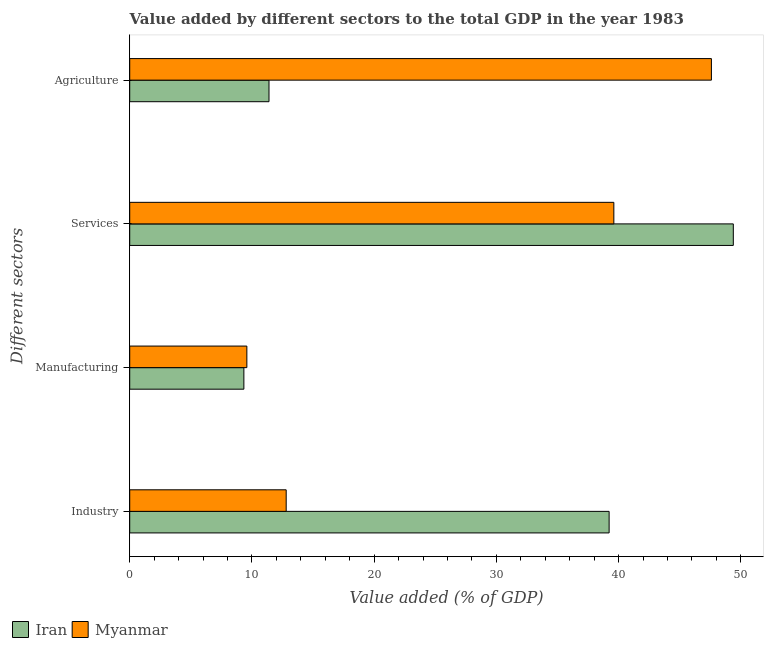How many different coloured bars are there?
Offer a very short reply. 2. How many groups of bars are there?
Provide a short and direct response. 4. Are the number of bars per tick equal to the number of legend labels?
Your answer should be compact. Yes. Are the number of bars on each tick of the Y-axis equal?
Your answer should be very brief. Yes. How many bars are there on the 2nd tick from the top?
Make the answer very short. 2. What is the label of the 2nd group of bars from the top?
Give a very brief answer. Services. What is the value added by industrial sector in Myanmar?
Provide a succinct answer. 12.8. Across all countries, what is the maximum value added by manufacturing sector?
Make the answer very short. 9.58. Across all countries, what is the minimum value added by manufacturing sector?
Ensure brevity in your answer.  9.34. In which country was the value added by industrial sector maximum?
Ensure brevity in your answer.  Iran. In which country was the value added by manufacturing sector minimum?
Offer a very short reply. Iran. What is the total value added by industrial sector in the graph?
Offer a very short reply. 52.02. What is the difference between the value added by industrial sector in Myanmar and that in Iran?
Your answer should be compact. -26.42. What is the difference between the value added by industrial sector in Myanmar and the value added by agricultural sector in Iran?
Give a very brief answer. 1.41. What is the average value added by agricultural sector per country?
Ensure brevity in your answer.  29.49. What is the difference between the value added by manufacturing sector and value added by industrial sector in Iran?
Your answer should be very brief. -29.88. What is the ratio of the value added by services sector in Myanmar to that in Iran?
Provide a succinct answer. 0.8. What is the difference between the highest and the second highest value added by services sector?
Keep it short and to the point. 9.77. What is the difference between the highest and the lowest value added by agricultural sector?
Your response must be concise. 36.2. Is it the case that in every country, the sum of the value added by services sector and value added by manufacturing sector is greater than the sum of value added by agricultural sector and value added by industrial sector?
Your answer should be compact. No. What does the 1st bar from the top in Services represents?
Make the answer very short. Myanmar. What does the 2nd bar from the bottom in Agriculture represents?
Keep it short and to the point. Myanmar. Are all the bars in the graph horizontal?
Provide a short and direct response. Yes. What is the difference between two consecutive major ticks on the X-axis?
Provide a succinct answer. 10. Are the values on the major ticks of X-axis written in scientific E-notation?
Provide a succinct answer. No. Where does the legend appear in the graph?
Make the answer very short. Bottom left. How many legend labels are there?
Your response must be concise. 2. How are the legend labels stacked?
Offer a terse response. Horizontal. What is the title of the graph?
Make the answer very short. Value added by different sectors to the total GDP in the year 1983. What is the label or title of the X-axis?
Your response must be concise. Value added (% of GDP). What is the label or title of the Y-axis?
Keep it short and to the point. Different sectors. What is the Value added (% of GDP) in Iran in Industry?
Your response must be concise. 39.22. What is the Value added (% of GDP) in Myanmar in Industry?
Make the answer very short. 12.8. What is the Value added (% of GDP) of Iran in Manufacturing?
Your answer should be very brief. 9.34. What is the Value added (% of GDP) in Myanmar in Manufacturing?
Give a very brief answer. 9.58. What is the Value added (% of GDP) in Iran in Services?
Provide a succinct answer. 49.38. What is the Value added (% of GDP) in Myanmar in Services?
Your answer should be very brief. 39.61. What is the Value added (% of GDP) in Iran in Agriculture?
Keep it short and to the point. 11.39. What is the Value added (% of GDP) in Myanmar in Agriculture?
Offer a terse response. 47.59. Across all Different sectors, what is the maximum Value added (% of GDP) in Iran?
Keep it short and to the point. 49.38. Across all Different sectors, what is the maximum Value added (% of GDP) of Myanmar?
Give a very brief answer. 47.59. Across all Different sectors, what is the minimum Value added (% of GDP) in Iran?
Provide a succinct answer. 9.34. Across all Different sectors, what is the minimum Value added (% of GDP) in Myanmar?
Offer a very short reply. 9.58. What is the total Value added (% of GDP) of Iran in the graph?
Offer a terse response. 109.34. What is the total Value added (% of GDP) of Myanmar in the graph?
Provide a succinct answer. 109.58. What is the difference between the Value added (% of GDP) of Iran in Industry and that in Manufacturing?
Provide a succinct answer. 29.88. What is the difference between the Value added (% of GDP) in Myanmar in Industry and that in Manufacturing?
Keep it short and to the point. 3.22. What is the difference between the Value added (% of GDP) in Iran in Industry and that in Services?
Offer a very short reply. -10.16. What is the difference between the Value added (% of GDP) of Myanmar in Industry and that in Services?
Your answer should be compact. -26.81. What is the difference between the Value added (% of GDP) of Iran in Industry and that in Agriculture?
Offer a very short reply. 27.83. What is the difference between the Value added (% of GDP) in Myanmar in Industry and that in Agriculture?
Ensure brevity in your answer.  -34.79. What is the difference between the Value added (% of GDP) in Iran in Manufacturing and that in Services?
Keep it short and to the point. -40.04. What is the difference between the Value added (% of GDP) of Myanmar in Manufacturing and that in Services?
Provide a succinct answer. -30.02. What is the difference between the Value added (% of GDP) in Iran in Manufacturing and that in Agriculture?
Provide a succinct answer. -2.06. What is the difference between the Value added (% of GDP) of Myanmar in Manufacturing and that in Agriculture?
Provide a succinct answer. -38.01. What is the difference between the Value added (% of GDP) in Iran in Services and that in Agriculture?
Your answer should be very brief. 37.99. What is the difference between the Value added (% of GDP) of Myanmar in Services and that in Agriculture?
Provide a succinct answer. -7.98. What is the difference between the Value added (% of GDP) in Iran in Industry and the Value added (% of GDP) in Myanmar in Manufacturing?
Provide a short and direct response. 29.64. What is the difference between the Value added (% of GDP) of Iran in Industry and the Value added (% of GDP) of Myanmar in Services?
Your answer should be very brief. -0.39. What is the difference between the Value added (% of GDP) in Iran in Industry and the Value added (% of GDP) in Myanmar in Agriculture?
Your answer should be very brief. -8.37. What is the difference between the Value added (% of GDP) in Iran in Manufacturing and the Value added (% of GDP) in Myanmar in Services?
Offer a terse response. -30.27. What is the difference between the Value added (% of GDP) of Iran in Manufacturing and the Value added (% of GDP) of Myanmar in Agriculture?
Provide a succinct answer. -38.25. What is the difference between the Value added (% of GDP) in Iran in Services and the Value added (% of GDP) in Myanmar in Agriculture?
Make the answer very short. 1.79. What is the average Value added (% of GDP) of Iran per Different sectors?
Your answer should be compact. 27.33. What is the average Value added (% of GDP) of Myanmar per Different sectors?
Provide a succinct answer. 27.4. What is the difference between the Value added (% of GDP) in Iran and Value added (% of GDP) in Myanmar in Industry?
Your answer should be very brief. 26.42. What is the difference between the Value added (% of GDP) of Iran and Value added (% of GDP) of Myanmar in Manufacturing?
Your answer should be compact. -0.24. What is the difference between the Value added (% of GDP) in Iran and Value added (% of GDP) in Myanmar in Services?
Give a very brief answer. 9.77. What is the difference between the Value added (% of GDP) of Iran and Value added (% of GDP) of Myanmar in Agriculture?
Ensure brevity in your answer.  -36.2. What is the ratio of the Value added (% of GDP) in Iran in Industry to that in Manufacturing?
Offer a very short reply. 4.2. What is the ratio of the Value added (% of GDP) in Myanmar in Industry to that in Manufacturing?
Offer a terse response. 1.34. What is the ratio of the Value added (% of GDP) in Iran in Industry to that in Services?
Offer a terse response. 0.79. What is the ratio of the Value added (% of GDP) of Myanmar in Industry to that in Services?
Keep it short and to the point. 0.32. What is the ratio of the Value added (% of GDP) of Iran in Industry to that in Agriculture?
Provide a succinct answer. 3.44. What is the ratio of the Value added (% of GDP) in Myanmar in Industry to that in Agriculture?
Your answer should be very brief. 0.27. What is the ratio of the Value added (% of GDP) of Iran in Manufacturing to that in Services?
Your answer should be very brief. 0.19. What is the ratio of the Value added (% of GDP) of Myanmar in Manufacturing to that in Services?
Your answer should be compact. 0.24. What is the ratio of the Value added (% of GDP) of Iran in Manufacturing to that in Agriculture?
Offer a very short reply. 0.82. What is the ratio of the Value added (% of GDP) of Myanmar in Manufacturing to that in Agriculture?
Make the answer very short. 0.2. What is the ratio of the Value added (% of GDP) of Iran in Services to that in Agriculture?
Make the answer very short. 4.33. What is the ratio of the Value added (% of GDP) of Myanmar in Services to that in Agriculture?
Offer a very short reply. 0.83. What is the difference between the highest and the second highest Value added (% of GDP) in Iran?
Offer a terse response. 10.16. What is the difference between the highest and the second highest Value added (% of GDP) in Myanmar?
Keep it short and to the point. 7.98. What is the difference between the highest and the lowest Value added (% of GDP) in Iran?
Your answer should be very brief. 40.04. What is the difference between the highest and the lowest Value added (% of GDP) of Myanmar?
Your answer should be very brief. 38.01. 